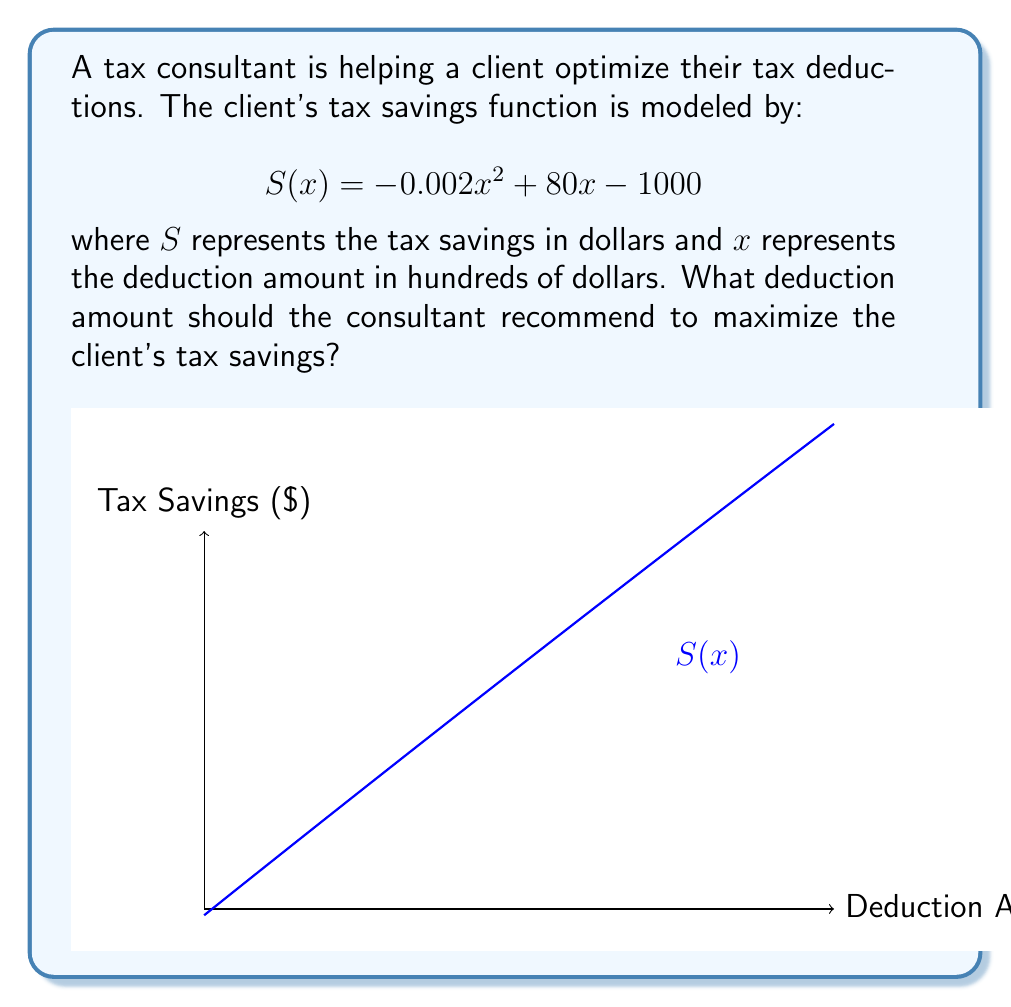Give your solution to this math problem. To find the optimal deduction amount, we need to find the maximum of the function $S(x)$. This occurs where the derivative of $S(x)$ equals zero.

Step 1: Find the derivative of $S(x)$
$$S'(x) = -0.004x + 80$$

Step 2: Set $S'(x) = 0$ and solve for $x$
$$-0.004x + 80 = 0$$
$$-0.004x = -80$$
$$x = \frac{-80}{-0.004} = 20,000$$

Step 3: Verify this is a maximum (not a minimum)
The second derivative is $S''(x) = -0.004$, which is negative, confirming this is a maximum.

Step 4: Interpret the result
Since $x$ represents hundreds of dollars, the optimal deduction amount is $20,000 \times 100 = \$2,000,000$.

Step 5: Calculate the maximum tax savings
$$S(20000) = -0.002(20000)^2 + 80(20000) - 1000 = 799,000$$

Therefore, the maximum tax savings is $\$799,000$.
Answer: $\$2,000,000$ deduction for $\$799,000$ maximum savings 